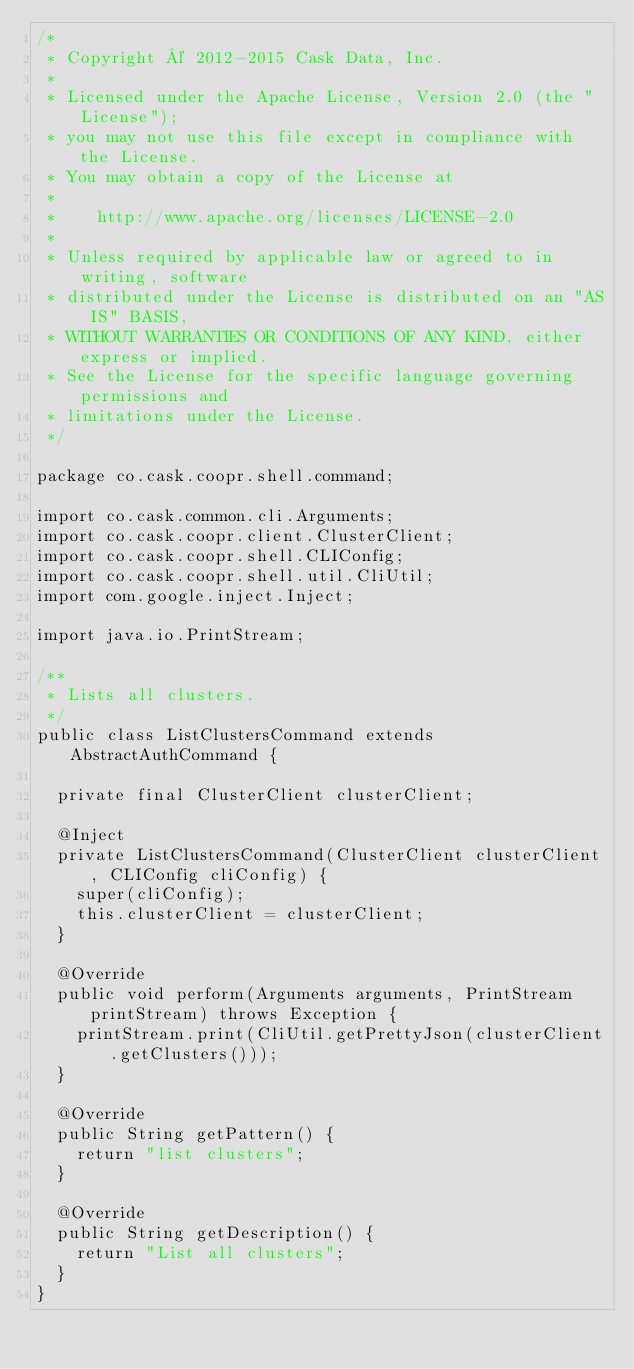Convert code to text. <code><loc_0><loc_0><loc_500><loc_500><_Java_>/*
 * Copyright © 2012-2015 Cask Data, Inc.
 *
 * Licensed under the Apache License, Version 2.0 (the "License");
 * you may not use this file except in compliance with the License.
 * You may obtain a copy of the License at
 *
 *    http://www.apache.org/licenses/LICENSE-2.0
 *
 * Unless required by applicable law or agreed to in writing, software
 * distributed under the License is distributed on an "AS IS" BASIS,
 * WITHOUT WARRANTIES OR CONDITIONS OF ANY KIND, either express or implied.
 * See the License for the specific language governing permissions and
 * limitations under the License.
 */

package co.cask.coopr.shell.command;

import co.cask.common.cli.Arguments;
import co.cask.coopr.client.ClusterClient;
import co.cask.coopr.shell.CLIConfig;
import co.cask.coopr.shell.util.CliUtil;
import com.google.inject.Inject;

import java.io.PrintStream;

/**
 * Lists all clusters.
 */
public class ListClustersCommand extends AbstractAuthCommand {

  private final ClusterClient clusterClient;

  @Inject
  private ListClustersCommand(ClusterClient clusterClient, CLIConfig cliConfig) {
    super(cliConfig);
    this.clusterClient = clusterClient;
  }

  @Override
  public void perform(Arguments arguments, PrintStream printStream) throws Exception {
    printStream.print(CliUtil.getPrettyJson(clusterClient.getClusters()));
  }

  @Override
  public String getPattern() {
    return "list clusters";
  }

  @Override
  public String getDescription() {
    return "List all clusters";
  }
}
</code> 